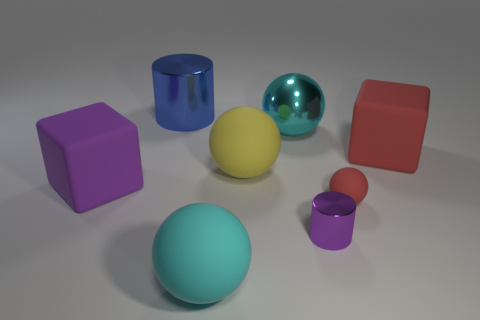Is the number of big cyan rubber objects that are behind the tiny purple thing less than the number of red rubber spheres?
Provide a short and direct response. Yes. Are there any metal spheres of the same size as the blue thing?
Offer a very short reply. Yes. Is the color of the tiny matte sphere the same as the matte object that is on the left side of the big cyan matte ball?
Your answer should be very brief. No. How many blue cylinders are in front of the large block that is on the right side of the large purple block?
Offer a very short reply. 0. There is a cylinder behind the block to the right of the big cyan shiny ball; what color is it?
Offer a very short reply. Blue. What is the thing that is right of the purple cylinder and behind the small matte sphere made of?
Offer a terse response. Rubber. Is there a small blue metallic thing of the same shape as the tiny rubber thing?
Make the answer very short. No. Does the cyan thing behind the large purple matte block have the same shape as the big red object?
Keep it short and to the point. No. How many big spheres are both in front of the large cyan metal object and behind the big cyan matte sphere?
Provide a short and direct response. 1. What shape is the thing behind the large cyan metallic sphere?
Your response must be concise. Cylinder. 